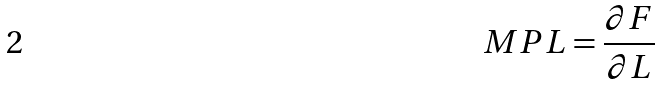Convert formula to latex. <formula><loc_0><loc_0><loc_500><loc_500>M P L = \frac { \partial F } { \partial L }</formula> 